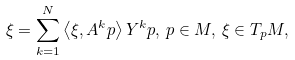Convert formula to latex. <formula><loc_0><loc_0><loc_500><loc_500>\xi = \sum _ { k = 1 } ^ { N } \left \langle \xi , A ^ { k } p \right \rangle Y ^ { k } p , \, p \in M , \, \xi \in T _ { p } M ,</formula> 